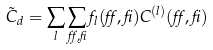<formula> <loc_0><loc_0><loc_500><loc_500>\tilde { C } _ { d } = \sum _ { l } \sum _ { \alpha , \beta } f _ { l } ( \alpha , \beta ) C ^ { ( l ) } ( \alpha , \beta )</formula> 